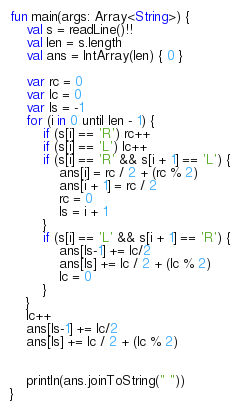Convert code to text. <code><loc_0><loc_0><loc_500><loc_500><_Kotlin_>fun main(args: Array<String>) {
    val s = readLine()!!
    val len = s.length
    val ans = IntArray(len) { 0 }

    var rc = 0
    var lc = 0
    var ls = -1
    for (i in 0 until len - 1) {
        if (s[i] == 'R') rc++
        if (s[i] == 'L') lc++
        if (s[i] == 'R' && s[i + 1] == 'L') {
            ans[i] = rc / 2 + (rc % 2)
            ans[i + 1] = rc / 2
            rc = 0
            ls = i + 1
        }
        if (s[i] == 'L' && s[i + 1] == 'R') {
            ans[ls-1] += lc/2
            ans[ls] += lc / 2 + (lc % 2)
            lc = 0
        }
    }
    lc++
    ans[ls-1] += lc/2
    ans[ls] += lc / 2 + (lc % 2)


    println(ans.joinToString(" "))
}
</code> 